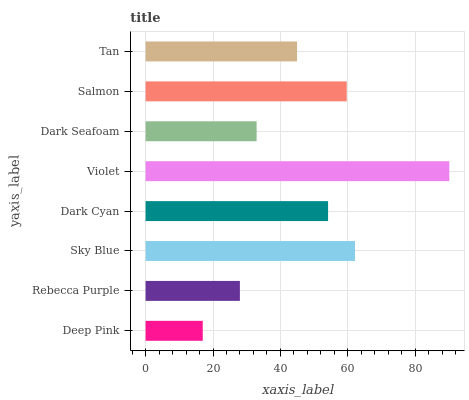Is Deep Pink the minimum?
Answer yes or no. Yes. Is Violet the maximum?
Answer yes or no. Yes. Is Rebecca Purple the minimum?
Answer yes or no. No. Is Rebecca Purple the maximum?
Answer yes or no. No. Is Rebecca Purple greater than Deep Pink?
Answer yes or no. Yes. Is Deep Pink less than Rebecca Purple?
Answer yes or no. Yes. Is Deep Pink greater than Rebecca Purple?
Answer yes or no. No. Is Rebecca Purple less than Deep Pink?
Answer yes or no. No. Is Dark Cyan the high median?
Answer yes or no. Yes. Is Tan the low median?
Answer yes or no. Yes. Is Dark Seafoam the high median?
Answer yes or no. No. Is Dark Seafoam the low median?
Answer yes or no. No. 